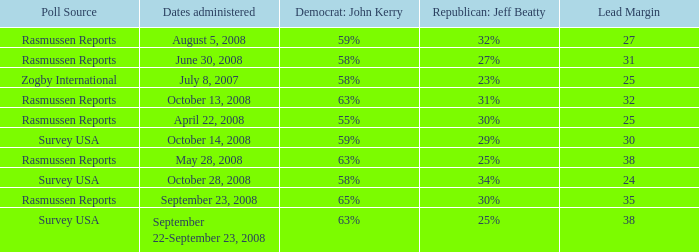What percent is the lead margin of 25 that Republican: Jeff Beatty has according to poll source Rasmussen Reports? 30%. 